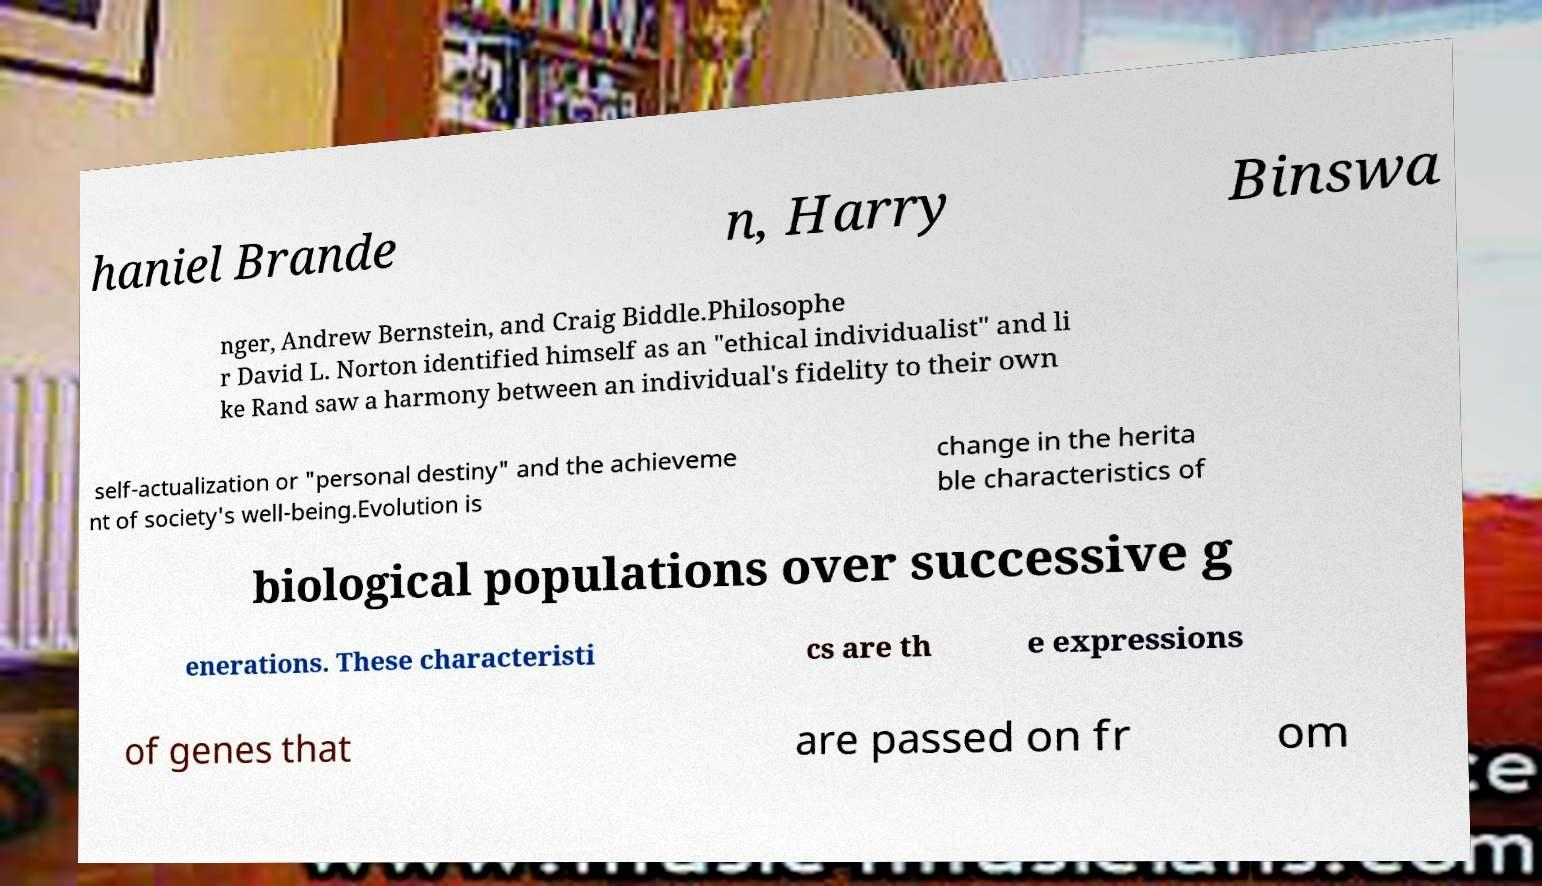Can you accurately transcribe the text from the provided image for me? haniel Brande n, Harry Binswa nger, Andrew Bernstein, and Craig Biddle.Philosophe r David L. Norton identified himself as an "ethical individualist" and li ke Rand saw a harmony between an individual's fidelity to their own self-actualization or "personal destiny" and the achieveme nt of society's well-being.Evolution is change in the herita ble characteristics of biological populations over successive g enerations. These characteristi cs are th e expressions of genes that are passed on fr om 